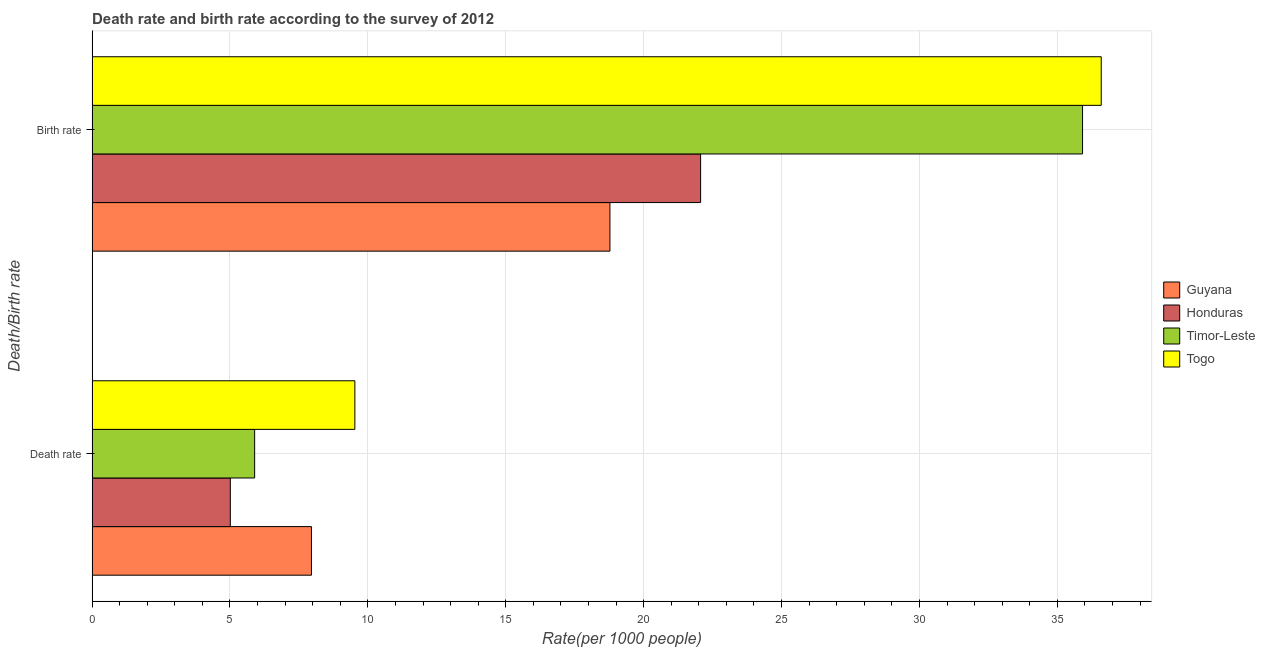How many different coloured bars are there?
Your response must be concise. 4. How many groups of bars are there?
Give a very brief answer. 2. Are the number of bars on each tick of the Y-axis equal?
Your response must be concise. Yes. What is the label of the 2nd group of bars from the top?
Ensure brevity in your answer.  Death rate. What is the death rate in Guyana?
Your response must be concise. 7.95. Across all countries, what is the maximum birth rate?
Make the answer very short. 36.59. Across all countries, what is the minimum birth rate?
Offer a very short reply. 18.78. In which country was the death rate maximum?
Make the answer very short. Togo. In which country was the birth rate minimum?
Offer a very short reply. Guyana. What is the total birth rate in the graph?
Offer a very short reply. 113.35. What is the difference between the death rate in Timor-Leste and that in Togo?
Your response must be concise. -3.63. What is the difference between the birth rate in Guyana and the death rate in Timor-Leste?
Your response must be concise. 12.88. What is the average death rate per country?
Give a very brief answer. 7.1. What is the difference between the death rate and birth rate in Timor-Leste?
Keep it short and to the point. -30.02. What is the ratio of the birth rate in Timor-Leste to that in Guyana?
Give a very brief answer. 1.91. In how many countries, is the birth rate greater than the average birth rate taken over all countries?
Offer a terse response. 2. What does the 1st bar from the top in Death rate represents?
Keep it short and to the point. Togo. What does the 4th bar from the bottom in Birth rate represents?
Ensure brevity in your answer.  Togo. How many bars are there?
Keep it short and to the point. 8. How many countries are there in the graph?
Your response must be concise. 4. What is the difference between two consecutive major ticks on the X-axis?
Your response must be concise. 5. Does the graph contain any zero values?
Give a very brief answer. No. Does the graph contain grids?
Make the answer very short. Yes. Where does the legend appear in the graph?
Provide a short and direct response. Center right. How many legend labels are there?
Offer a terse response. 4. What is the title of the graph?
Give a very brief answer. Death rate and birth rate according to the survey of 2012. What is the label or title of the X-axis?
Offer a very short reply. Rate(per 1000 people). What is the label or title of the Y-axis?
Give a very brief answer. Death/Birth rate. What is the Rate(per 1000 people) in Guyana in Death rate?
Provide a short and direct response. 7.95. What is the Rate(per 1000 people) of Honduras in Death rate?
Offer a terse response. 5.01. What is the Rate(per 1000 people) of Timor-Leste in Death rate?
Offer a terse response. 5.89. What is the Rate(per 1000 people) of Togo in Death rate?
Ensure brevity in your answer.  9.53. What is the Rate(per 1000 people) in Guyana in Birth rate?
Offer a terse response. 18.78. What is the Rate(per 1000 people) of Honduras in Birth rate?
Your response must be concise. 22.07. What is the Rate(per 1000 people) in Timor-Leste in Birth rate?
Your answer should be compact. 35.91. What is the Rate(per 1000 people) in Togo in Birth rate?
Give a very brief answer. 36.59. Across all Death/Birth rate, what is the maximum Rate(per 1000 people) of Guyana?
Ensure brevity in your answer.  18.78. Across all Death/Birth rate, what is the maximum Rate(per 1000 people) of Honduras?
Offer a very short reply. 22.07. Across all Death/Birth rate, what is the maximum Rate(per 1000 people) of Timor-Leste?
Your answer should be very brief. 35.91. Across all Death/Birth rate, what is the maximum Rate(per 1000 people) of Togo?
Give a very brief answer. 36.59. Across all Death/Birth rate, what is the minimum Rate(per 1000 people) in Guyana?
Offer a terse response. 7.95. Across all Death/Birth rate, what is the minimum Rate(per 1000 people) in Honduras?
Ensure brevity in your answer.  5.01. Across all Death/Birth rate, what is the minimum Rate(per 1000 people) in Timor-Leste?
Provide a succinct answer. 5.89. Across all Death/Birth rate, what is the minimum Rate(per 1000 people) in Togo?
Give a very brief answer. 9.53. What is the total Rate(per 1000 people) in Guyana in the graph?
Your response must be concise. 26.73. What is the total Rate(per 1000 people) of Honduras in the graph?
Provide a succinct answer. 27.08. What is the total Rate(per 1000 people) in Timor-Leste in the graph?
Ensure brevity in your answer.  41.81. What is the total Rate(per 1000 people) of Togo in the graph?
Your response must be concise. 46.12. What is the difference between the Rate(per 1000 people) of Guyana in Death rate and that in Birth rate?
Make the answer very short. -10.82. What is the difference between the Rate(per 1000 people) of Honduras in Death rate and that in Birth rate?
Your response must be concise. -17.05. What is the difference between the Rate(per 1000 people) in Timor-Leste in Death rate and that in Birth rate?
Your answer should be compact. -30.02. What is the difference between the Rate(per 1000 people) of Togo in Death rate and that in Birth rate?
Provide a succinct answer. -27.06. What is the difference between the Rate(per 1000 people) of Guyana in Death rate and the Rate(per 1000 people) of Honduras in Birth rate?
Provide a short and direct response. -14.11. What is the difference between the Rate(per 1000 people) in Guyana in Death rate and the Rate(per 1000 people) in Timor-Leste in Birth rate?
Your answer should be compact. -27.96. What is the difference between the Rate(per 1000 people) of Guyana in Death rate and the Rate(per 1000 people) of Togo in Birth rate?
Your answer should be compact. -28.64. What is the difference between the Rate(per 1000 people) in Honduras in Death rate and the Rate(per 1000 people) in Timor-Leste in Birth rate?
Offer a very short reply. -30.9. What is the difference between the Rate(per 1000 people) of Honduras in Death rate and the Rate(per 1000 people) of Togo in Birth rate?
Provide a succinct answer. -31.58. What is the difference between the Rate(per 1000 people) in Timor-Leste in Death rate and the Rate(per 1000 people) in Togo in Birth rate?
Offer a terse response. -30.7. What is the average Rate(per 1000 people) in Guyana per Death/Birth rate?
Provide a succinct answer. 13.37. What is the average Rate(per 1000 people) in Honduras per Death/Birth rate?
Give a very brief answer. 13.54. What is the average Rate(per 1000 people) of Timor-Leste per Death/Birth rate?
Your answer should be very brief. 20.9. What is the average Rate(per 1000 people) of Togo per Death/Birth rate?
Provide a short and direct response. 23.06. What is the difference between the Rate(per 1000 people) in Guyana and Rate(per 1000 people) in Honduras in Death rate?
Offer a terse response. 2.94. What is the difference between the Rate(per 1000 people) of Guyana and Rate(per 1000 people) of Timor-Leste in Death rate?
Offer a very short reply. 2.06. What is the difference between the Rate(per 1000 people) in Guyana and Rate(per 1000 people) in Togo in Death rate?
Ensure brevity in your answer.  -1.57. What is the difference between the Rate(per 1000 people) in Honduras and Rate(per 1000 people) in Timor-Leste in Death rate?
Your response must be concise. -0.88. What is the difference between the Rate(per 1000 people) in Honduras and Rate(per 1000 people) in Togo in Death rate?
Make the answer very short. -4.52. What is the difference between the Rate(per 1000 people) in Timor-Leste and Rate(per 1000 people) in Togo in Death rate?
Provide a short and direct response. -3.63. What is the difference between the Rate(per 1000 people) in Guyana and Rate(per 1000 people) in Honduras in Birth rate?
Ensure brevity in your answer.  -3.29. What is the difference between the Rate(per 1000 people) in Guyana and Rate(per 1000 people) in Timor-Leste in Birth rate?
Ensure brevity in your answer.  -17.14. What is the difference between the Rate(per 1000 people) in Guyana and Rate(per 1000 people) in Togo in Birth rate?
Keep it short and to the point. -17.82. What is the difference between the Rate(per 1000 people) in Honduras and Rate(per 1000 people) in Timor-Leste in Birth rate?
Provide a succinct answer. -13.85. What is the difference between the Rate(per 1000 people) of Honduras and Rate(per 1000 people) of Togo in Birth rate?
Give a very brief answer. -14.53. What is the difference between the Rate(per 1000 people) in Timor-Leste and Rate(per 1000 people) in Togo in Birth rate?
Offer a terse response. -0.68. What is the ratio of the Rate(per 1000 people) in Guyana in Death rate to that in Birth rate?
Your answer should be very brief. 0.42. What is the ratio of the Rate(per 1000 people) in Honduras in Death rate to that in Birth rate?
Keep it short and to the point. 0.23. What is the ratio of the Rate(per 1000 people) in Timor-Leste in Death rate to that in Birth rate?
Provide a succinct answer. 0.16. What is the ratio of the Rate(per 1000 people) in Togo in Death rate to that in Birth rate?
Ensure brevity in your answer.  0.26. What is the difference between the highest and the second highest Rate(per 1000 people) of Guyana?
Provide a succinct answer. 10.82. What is the difference between the highest and the second highest Rate(per 1000 people) of Honduras?
Provide a succinct answer. 17.05. What is the difference between the highest and the second highest Rate(per 1000 people) of Timor-Leste?
Give a very brief answer. 30.02. What is the difference between the highest and the second highest Rate(per 1000 people) in Togo?
Your answer should be compact. 27.06. What is the difference between the highest and the lowest Rate(per 1000 people) in Guyana?
Keep it short and to the point. 10.82. What is the difference between the highest and the lowest Rate(per 1000 people) of Honduras?
Offer a terse response. 17.05. What is the difference between the highest and the lowest Rate(per 1000 people) of Timor-Leste?
Give a very brief answer. 30.02. What is the difference between the highest and the lowest Rate(per 1000 people) of Togo?
Offer a very short reply. 27.06. 